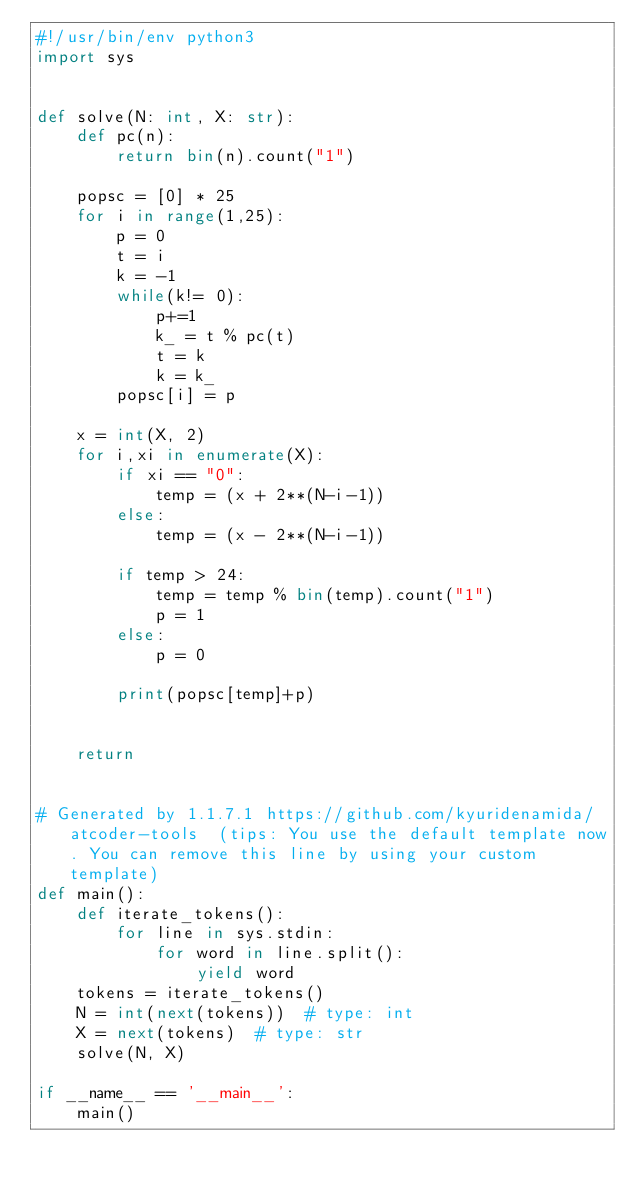<code> <loc_0><loc_0><loc_500><loc_500><_Python_>#!/usr/bin/env python3
import sys


def solve(N: int, X: str):
    def pc(n):
        return bin(n).count("1")
    
    popsc = [0] * 25
    for i in range(1,25):
        p = 0
        t = i
        k = -1
        while(k!= 0):
            p+=1
            k_ = t % pc(t)
            t = k
            k = k_
        popsc[i] = p

    x = int(X, 2)
    for i,xi in enumerate(X):
        if xi == "0":
            temp = (x + 2**(N-i-1))
        else:
            temp = (x - 2**(N-i-1))
        
        if temp > 24:
            temp = temp % bin(temp).count("1")
            p = 1
        else:
            p = 0

        print(popsc[temp]+p)

    
    return


# Generated by 1.1.7.1 https://github.com/kyuridenamida/atcoder-tools  (tips: You use the default template now. You can remove this line by using your custom template)
def main():
    def iterate_tokens():
        for line in sys.stdin:
            for word in line.split():
                yield word
    tokens = iterate_tokens()
    N = int(next(tokens))  # type: int
    X = next(tokens)  # type: str
    solve(N, X)

if __name__ == '__main__':
    main()
</code> 